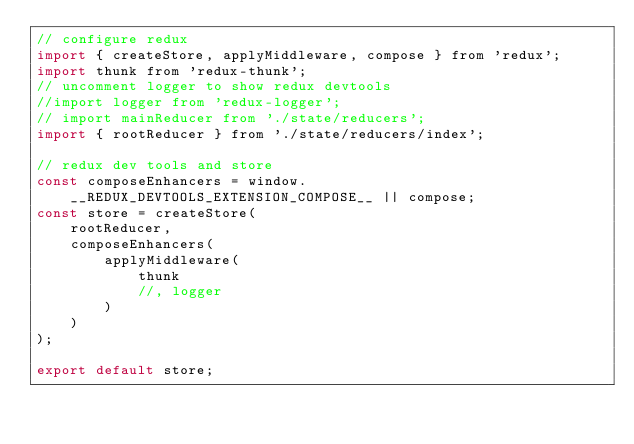<code> <loc_0><loc_0><loc_500><loc_500><_JavaScript_>// configure redux
import { createStore, applyMiddleware, compose } from 'redux';
import thunk from 'redux-thunk';
// uncomment logger to show redux devtools
//import logger from 'redux-logger';
// import mainReducer from './state/reducers';
import { rootReducer } from './state/reducers/index';

// redux dev tools and store
const composeEnhancers = window.__REDUX_DEVTOOLS_EXTENSION_COMPOSE__ || compose;
const store = createStore(
	rootReducer,
	composeEnhancers(
		applyMiddleware(
			thunk
			//, logger
		)
	)
);

export default store;
</code> 